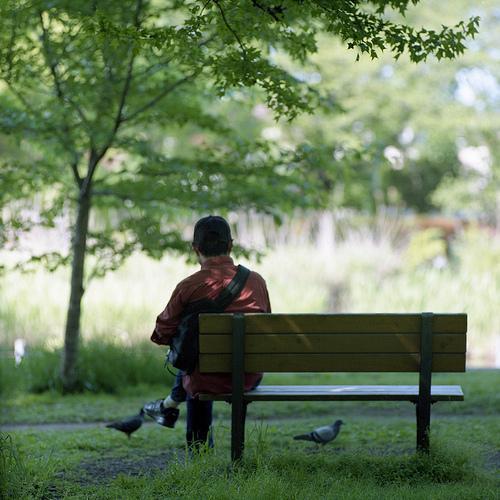How many people are shown?
Give a very brief answer. 1. How many birds are shown?
Give a very brief answer. 2. 